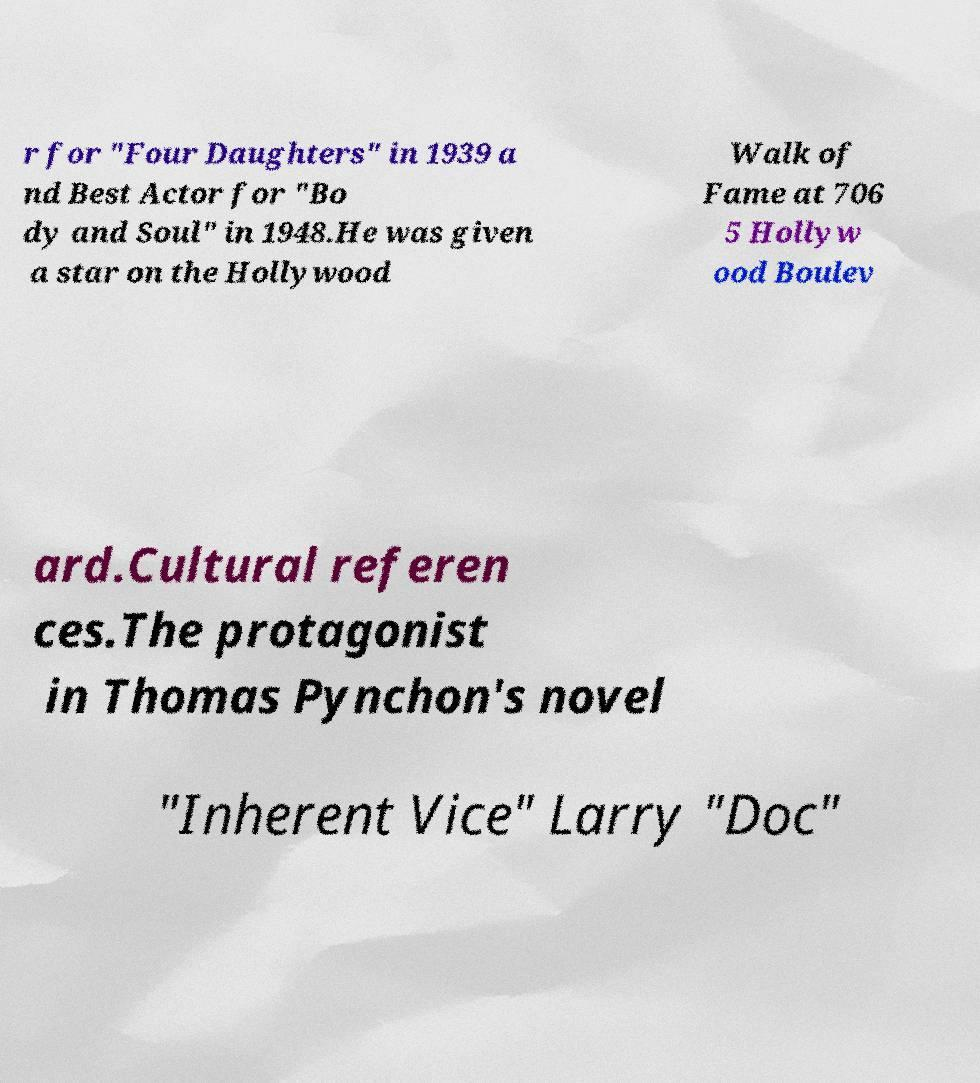What messages or text are displayed in this image? I need them in a readable, typed format. r for "Four Daughters" in 1939 a nd Best Actor for "Bo dy and Soul" in 1948.He was given a star on the Hollywood Walk of Fame at 706 5 Hollyw ood Boulev ard.Cultural referen ces.The protagonist in Thomas Pynchon's novel "Inherent Vice" Larry "Doc" 